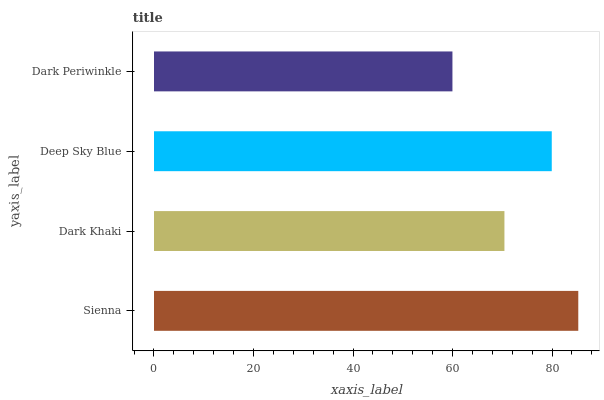Is Dark Periwinkle the minimum?
Answer yes or no. Yes. Is Sienna the maximum?
Answer yes or no. Yes. Is Dark Khaki the minimum?
Answer yes or no. No. Is Dark Khaki the maximum?
Answer yes or no. No. Is Sienna greater than Dark Khaki?
Answer yes or no. Yes. Is Dark Khaki less than Sienna?
Answer yes or no. Yes. Is Dark Khaki greater than Sienna?
Answer yes or no. No. Is Sienna less than Dark Khaki?
Answer yes or no. No. Is Deep Sky Blue the high median?
Answer yes or no. Yes. Is Dark Khaki the low median?
Answer yes or no. Yes. Is Sienna the high median?
Answer yes or no. No. Is Sienna the low median?
Answer yes or no. No. 